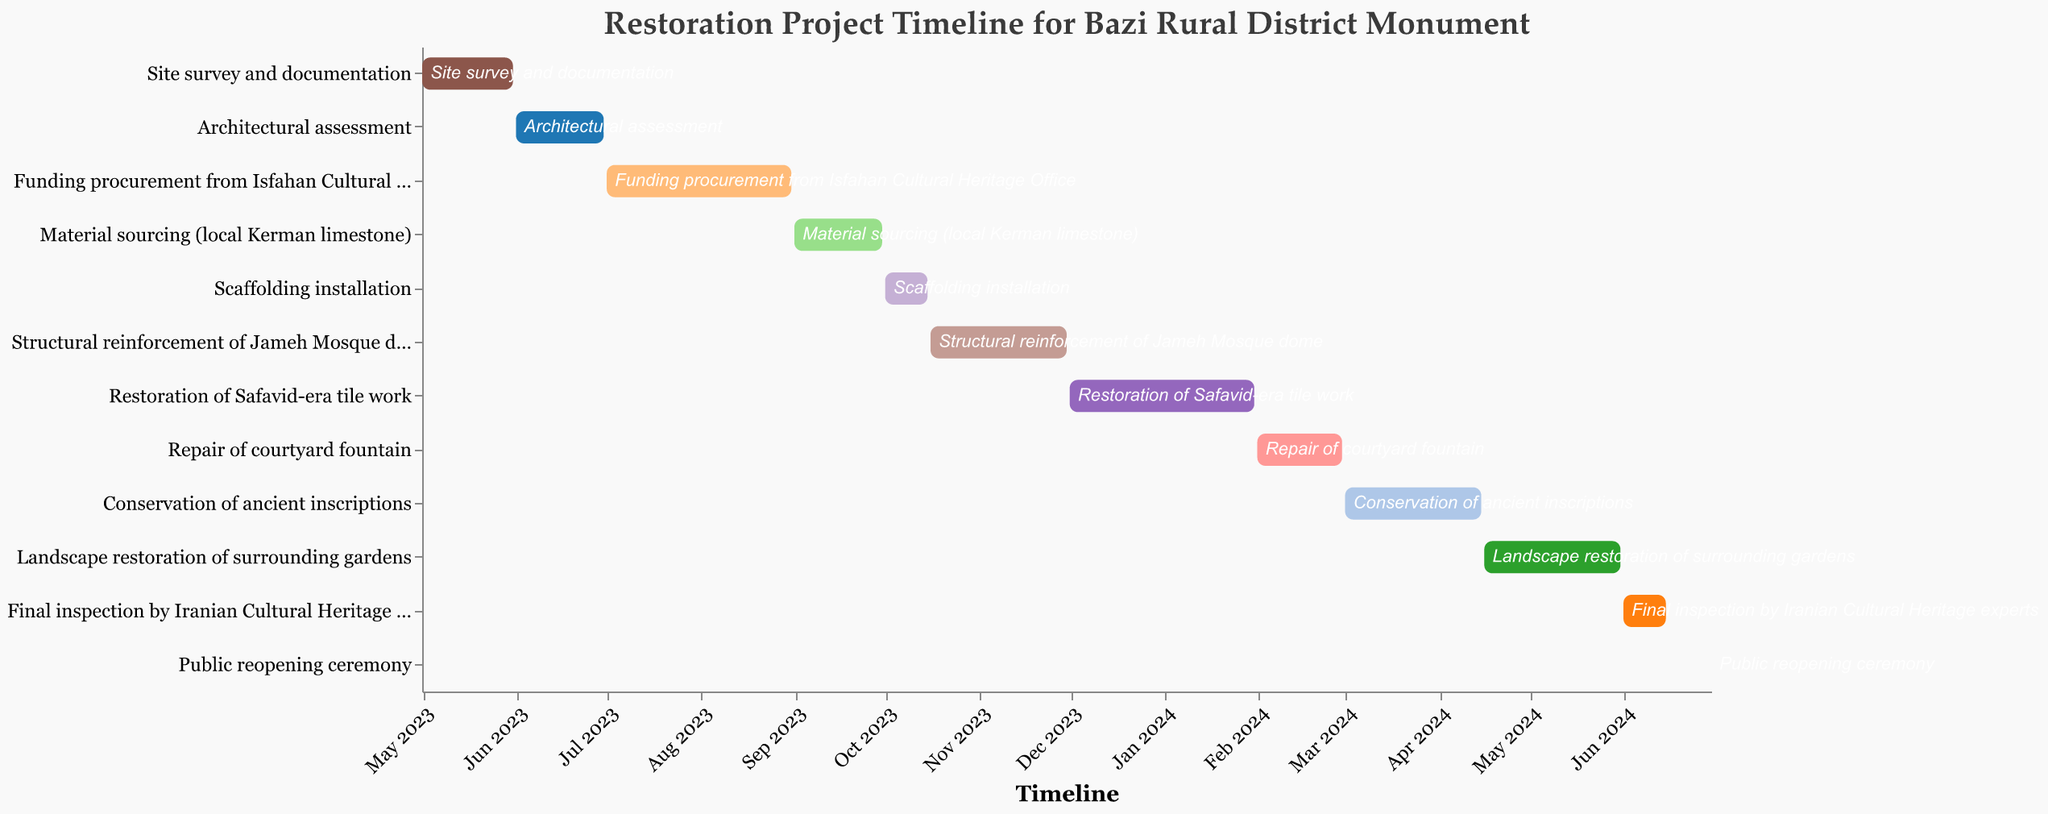When does the "Site survey and documentation" task start and end? The "Site survey and documentation" task starts on May 1, 2023, and ends on May 31, 2023. This can be observed from the leftmost start of the relevant bar in the Gantt chart to its endpoint.
Answer: Starts on May 1, 2023, and ends on May 31, 2023 What's the duration of the "Funding procurement from Isfahan Cultural Heritage Office" task? The "Funding procurement from Isfahan Cultural Heritage Office" task starts on July 1, 2023, and ends on August 31, 2023. Counting the total days from July 1 to August 31 gives a duration of 62 days.
Answer: 62 days Which task immediately follows "Material sourcing (local Kerman limestone)"? Following the timeline, "Scaffolding installation" immediately begins after "Material sourcing (local Kerman limestone)" task ends on September 30, 2023.
Answer: Scaffolding installation How long is the span between the start of "Restoration of Safavid-era tile work" and the end of "Repair of courtyard fountain"? "Restoration of Safavid-era tile work" starts on December 1, 2023, and "Repair of courtyard fountain" ends on February 29, 2024. Counting the span between December 1, 2023, to February 29, 2024, yields a duration of 90 days (December = 31, January = 31, February = 28).
Answer: 90 days Which month has the highest number of concurrent tasks? Observing the Gantt Chart, November 2023 seems to have two tasks overlapping: "Structural reinforcement of Jameh Mosque dome" and "Scaffolding installation". However, January 2024 has concurrent tasks as well: "Restoration of Safavid-era tile work" and "Repair of courtyard fountain".
Answer: January 2024 and November 2023 have the highest number of concurrent tasks What is the longest task in the restoration project timeline? By comparing the lengths of the bars, "Funding procurement from Isfahan Cultural Heritage Office" spans from July 1 to August 31, which is 62 days. This is longer than the other tasks.
Answer: Funding procurement from Isfahan Cultural Heritage Office Which tasks are scheduled to occur in 2024? Tasks in 2024 include "Restoration of Safavid-era tile work" (until January 31, 2024), "Repair of courtyard fountain" (February 1 to February 29, 2024), "Conservation of ancient inscriptions" (March 1 to April 15, 2024), "Landscape restoration of surrounding gardens" (April 16 to May 31, 2024), "Final inspection by Iranian Cultural Heritage experts" (June 1 to June 15, 2024), and "Public reopening ceremony" (June 30, 2024).
Answer: Several tasks occur in 2024 What is the gap between "Architectural assessment" and "Funding procurement from Isfahan Cultural Heritage Office"? "Architectural assessment" ends on June 30, 2023, and "Funding procurement from Isfahan Cultural Heritage Office" begins on July 1, 2023. Since July 1 follows immediately after June 30, there is no gap.
Answer: No gap Which task completes right before "Structural reinforcement of Jameh Mosque dome"? "Scaffolding installation" ends on October 15, 2023, and "Structural reinforcement of the Jameh Mosque dome" starts on October 16, 2023. Thus, "Scaffolding installation" completes right before "Structural reinforcement of the Jameh Mosque dome".
Answer: Scaffolding installation 